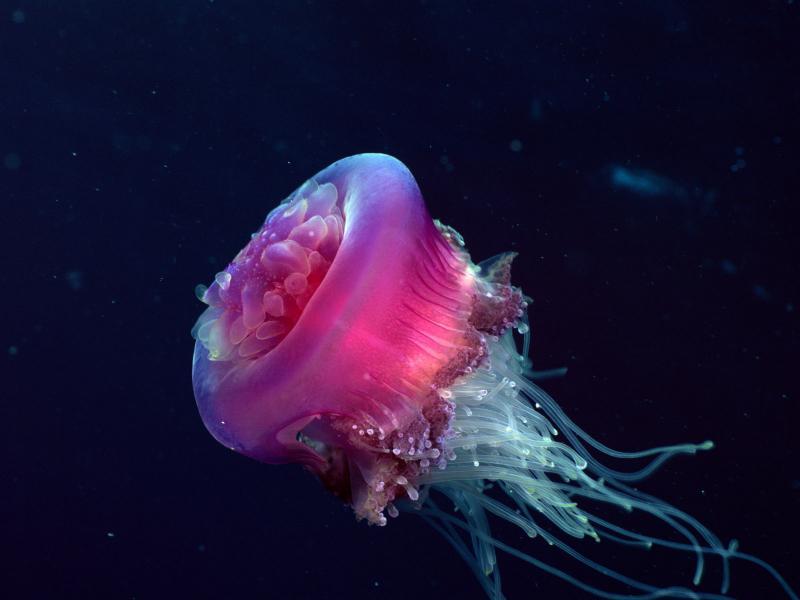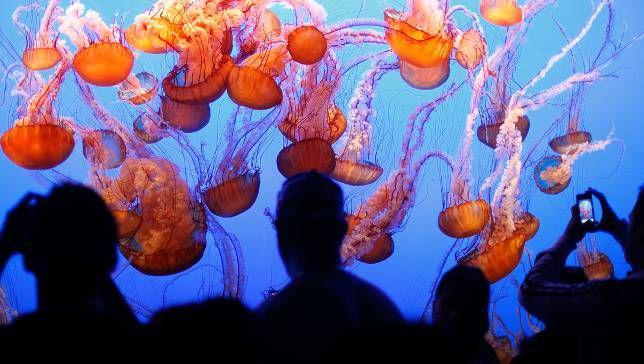The first image is the image on the left, the second image is the image on the right. Given the left and right images, does the statement "The pink jellyfish in the image on the left is against a black background." hold true? Answer yes or no. Yes. The first image is the image on the left, the second image is the image on the right. Considering the images on both sides, is "The left image shows at least one hot pink jellyfish trailing tendrils." valid? Answer yes or no. Yes. 